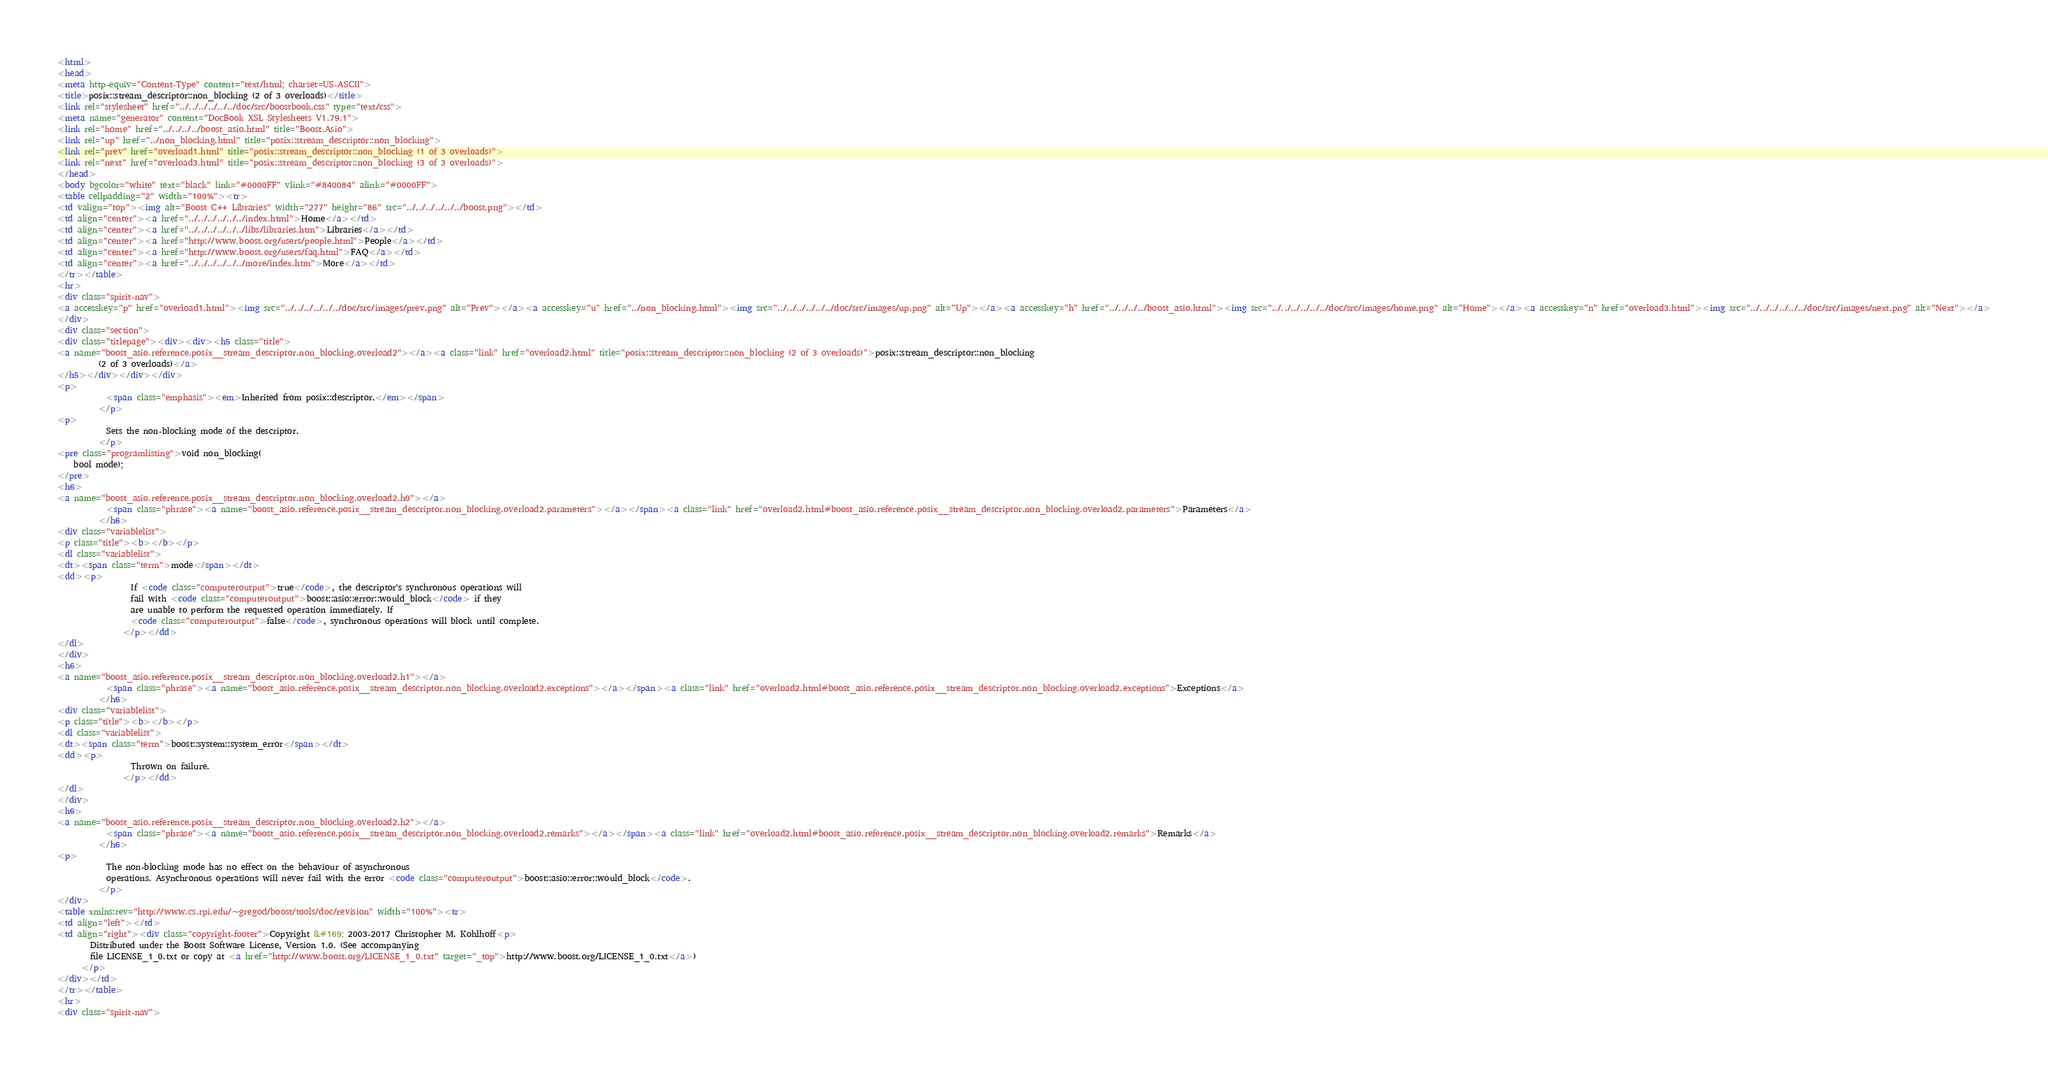Convert code to text. <code><loc_0><loc_0><loc_500><loc_500><_HTML_><html>
<head>
<meta http-equiv="Content-Type" content="text/html; charset=US-ASCII">
<title>posix::stream_descriptor::non_blocking (2 of 3 overloads)</title>
<link rel="stylesheet" href="../../../../../../doc/src/boostbook.css" type="text/css">
<meta name="generator" content="DocBook XSL Stylesheets V1.79.1">
<link rel="home" href="../../../../boost_asio.html" title="Boost.Asio">
<link rel="up" href="../non_blocking.html" title="posix::stream_descriptor::non_blocking">
<link rel="prev" href="overload1.html" title="posix::stream_descriptor::non_blocking (1 of 3 overloads)">
<link rel="next" href="overload3.html" title="posix::stream_descriptor::non_blocking (3 of 3 overloads)">
</head>
<body bgcolor="white" text="black" link="#0000FF" vlink="#840084" alink="#0000FF">
<table cellpadding="2" width="100%"><tr>
<td valign="top"><img alt="Boost C++ Libraries" width="277" height="86" src="../../../../../../boost.png"></td>
<td align="center"><a href="../../../../../../index.html">Home</a></td>
<td align="center"><a href="../../../../../../libs/libraries.htm">Libraries</a></td>
<td align="center"><a href="http://www.boost.org/users/people.html">People</a></td>
<td align="center"><a href="http://www.boost.org/users/faq.html">FAQ</a></td>
<td align="center"><a href="../../../../../../more/index.htm">More</a></td>
</tr></table>
<hr>
<div class="spirit-nav">
<a accesskey="p" href="overload1.html"><img src="../../../../../../doc/src/images/prev.png" alt="Prev"></a><a accesskey="u" href="../non_blocking.html"><img src="../../../../../../doc/src/images/up.png" alt="Up"></a><a accesskey="h" href="../../../../boost_asio.html"><img src="../../../../../../doc/src/images/home.png" alt="Home"></a><a accesskey="n" href="overload3.html"><img src="../../../../../../doc/src/images/next.png" alt="Next"></a>
</div>
<div class="section">
<div class="titlepage"><div><div><h5 class="title">
<a name="boost_asio.reference.posix__stream_descriptor.non_blocking.overload2"></a><a class="link" href="overload2.html" title="posix::stream_descriptor::non_blocking (2 of 3 overloads)">posix::stream_descriptor::non_blocking
          (2 of 3 overloads)</a>
</h5></div></div></div>
<p>
            <span class="emphasis"><em>Inherited from posix::descriptor.</em></span>
          </p>
<p>
            Sets the non-blocking mode of the descriptor.
          </p>
<pre class="programlisting">void non_blocking(
    bool mode);
</pre>
<h6>
<a name="boost_asio.reference.posix__stream_descriptor.non_blocking.overload2.h0"></a>
            <span class="phrase"><a name="boost_asio.reference.posix__stream_descriptor.non_blocking.overload2.parameters"></a></span><a class="link" href="overload2.html#boost_asio.reference.posix__stream_descriptor.non_blocking.overload2.parameters">Parameters</a>
          </h6>
<div class="variablelist">
<p class="title"><b></b></p>
<dl class="variablelist">
<dt><span class="term">mode</span></dt>
<dd><p>
                  If <code class="computeroutput">true</code>, the descriptor's synchronous operations will
                  fail with <code class="computeroutput">boost::asio::error::would_block</code> if they
                  are unable to perform the requested operation immediately. If
                  <code class="computeroutput">false</code>, synchronous operations will block until complete.
                </p></dd>
</dl>
</div>
<h6>
<a name="boost_asio.reference.posix__stream_descriptor.non_blocking.overload2.h1"></a>
            <span class="phrase"><a name="boost_asio.reference.posix__stream_descriptor.non_blocking.overload2.exceptions"></a></span><a class="link" href="overload2.html#boost_asio.reference.posix__stream_descriptor.non_blocking.overload2.exceptions">Exceptions</a>
          </h6>
<div class="variablelist">
<p class="title"><b></b></p>
<dl class="variablelist">
<dt><span class="term">boost::system::system_error</span></dt>
<dd><p>
                  Thrown on failure.
                </p></dd>
</dl>
</div>
<h6>
<a name="boost_asio.reference.posix__stream_descriptor.non_blocking.overload2.h2"></a>
            <span class="phrase"><a name="boost_asio.reference.posix__stream_descriptor.non_blocking.overload2.remarks"></a></span><a class="link" href="overload2.html#boost_asio.reference.posix__stream_descriptor.non_blocking.overload2.remarks">Remarks</a>
          </h6>
<p>
            The non-blocking mode has no effect on the behaviour of asynchronous
            operations. Asynchronous operations will never fail with the error <code class="computeroutput">boost::asio::error::would_block</code>.
          </p>
</div>
<table xmlns:rev="http://www.cs.rpi.edu/~gregod/boost/tools/doc/revision" width="100%"><tr>
<td align="left"></td>
<td align="right"><div class="copyright-footer">Copyright &#169; 2003-2017 Christopher M. Kohlhoff<p>
        Distributed under the Boost Software License, Version 1.0. (See accompanying
        file LICENSE_1_0.txt or copy at <a href="http://www.boost.org/LICENSE_1_0.txt" target="_top">http://www.boost.org/LICENSE_1_0.txt</a>)
      </p>
</div></td>
</tr></table>
<hr>
<div class="spirit-nav"></code> 